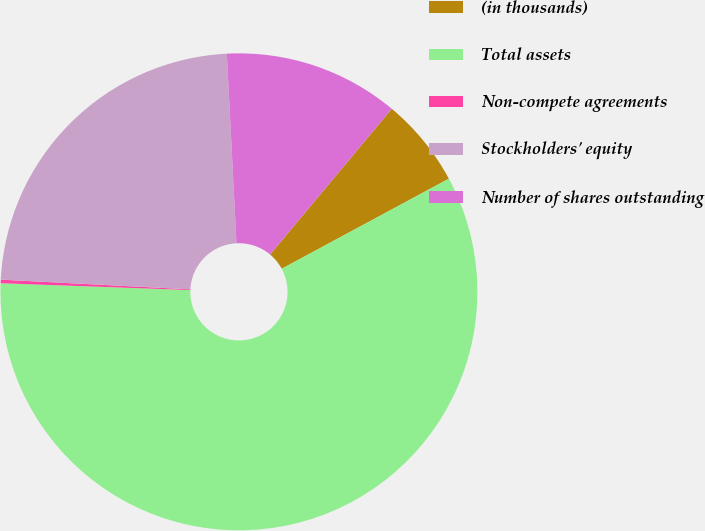Convert chart. <chart><loc_0><loc_0><loc_500><loc_500><pie_chart><fcel>(in thousands)<fcel>Total assets<fcel>Non-compete agreements<fcel>Stockholders' equity<fcel>Number of shares outstanding<nl><fcel>6.06%<fcel>58.44%<fcel>0.24%<fcel>23.38%<fcel>11.88%<nl></chart> 